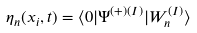<formula> <loc_0><loc_0><loc_500><loc_500>\eta _ { n } ( x _ { i } , t ) = \langle 0 | \Psi ^ { ( + ) ( I ) } | W _ { n } ^ { ( I ) } \rangle</formula> 